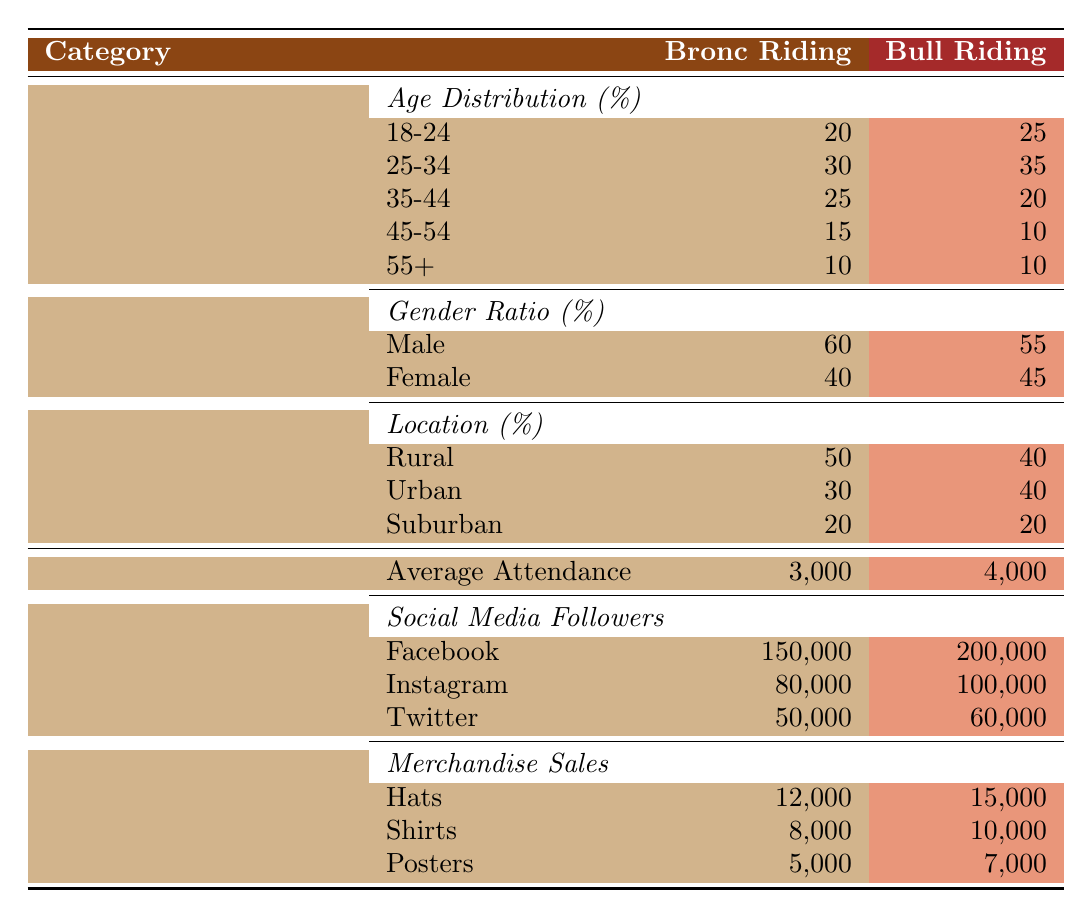What's the average attendance for bronc riding events? The average attendance is explicitly stated in the engagement statistics section for bronc riding, which shows a value of 3,000.
Answer: 3,000 Which age group has the highest percentage of fans in bull riding? Looking at the age distribution for bull riding events, the group 25-34 has the highest percentage at 35%.
Answer: 25-34 True or False: More merchandise sales were recorded for shirts in bronc riding compared to bull riding. The merchandise sales for bronc riding shirts is 8,000 while for bull riding it is 10,000, meaning fewer sales in bronc riding. Therefore, the statement is false.
Answer: False How many more social media followers does bull riding have on Facebook compared to bronc riding? On Facebook, bull riding has 200,000 followers and bronc riding has 150,000. The difference is calculated by subtracting 150,000 from 200,000, resulting in 50,000 more followers for bull riding.
Answer: 50,000 Which demographic location has the lowest percentage of fans for bronc riding? When examining the location percentages for bronc riding, suburban has the lowest percentage at 20%.
Answer: Suburban 